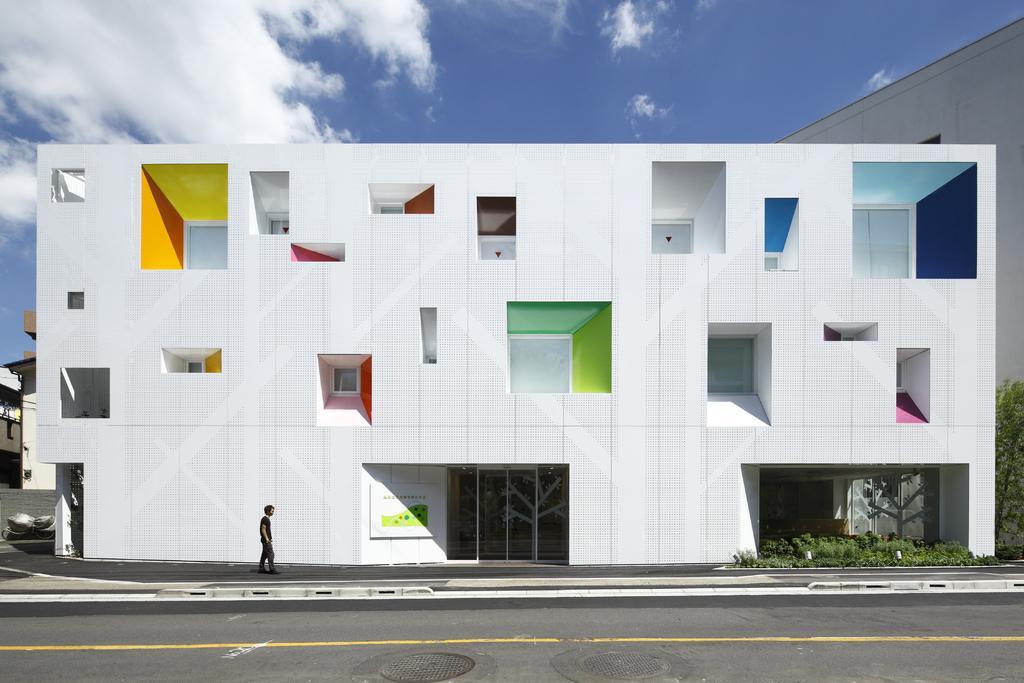How would you summarize this image in a sentence or two? These are clouds. Here we can see buildings, windows, plants and person. 